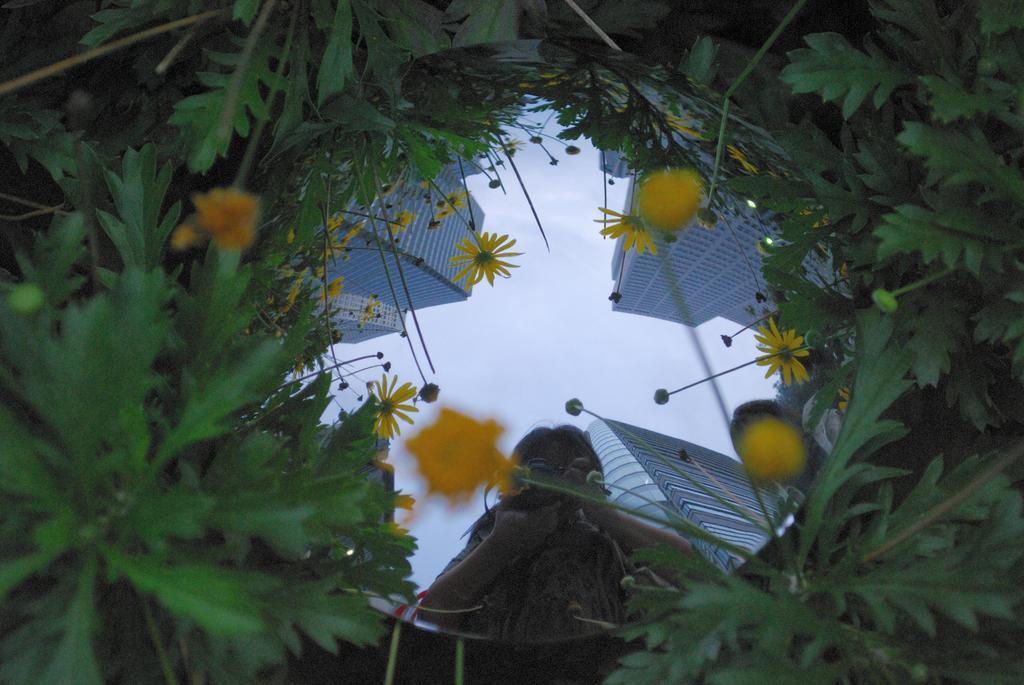Please provide a concise description of this image. Here we can see plants and flowers. This is a mirror. In the mirror we can see the reflection of a person, buildings, flowers, and sky. 